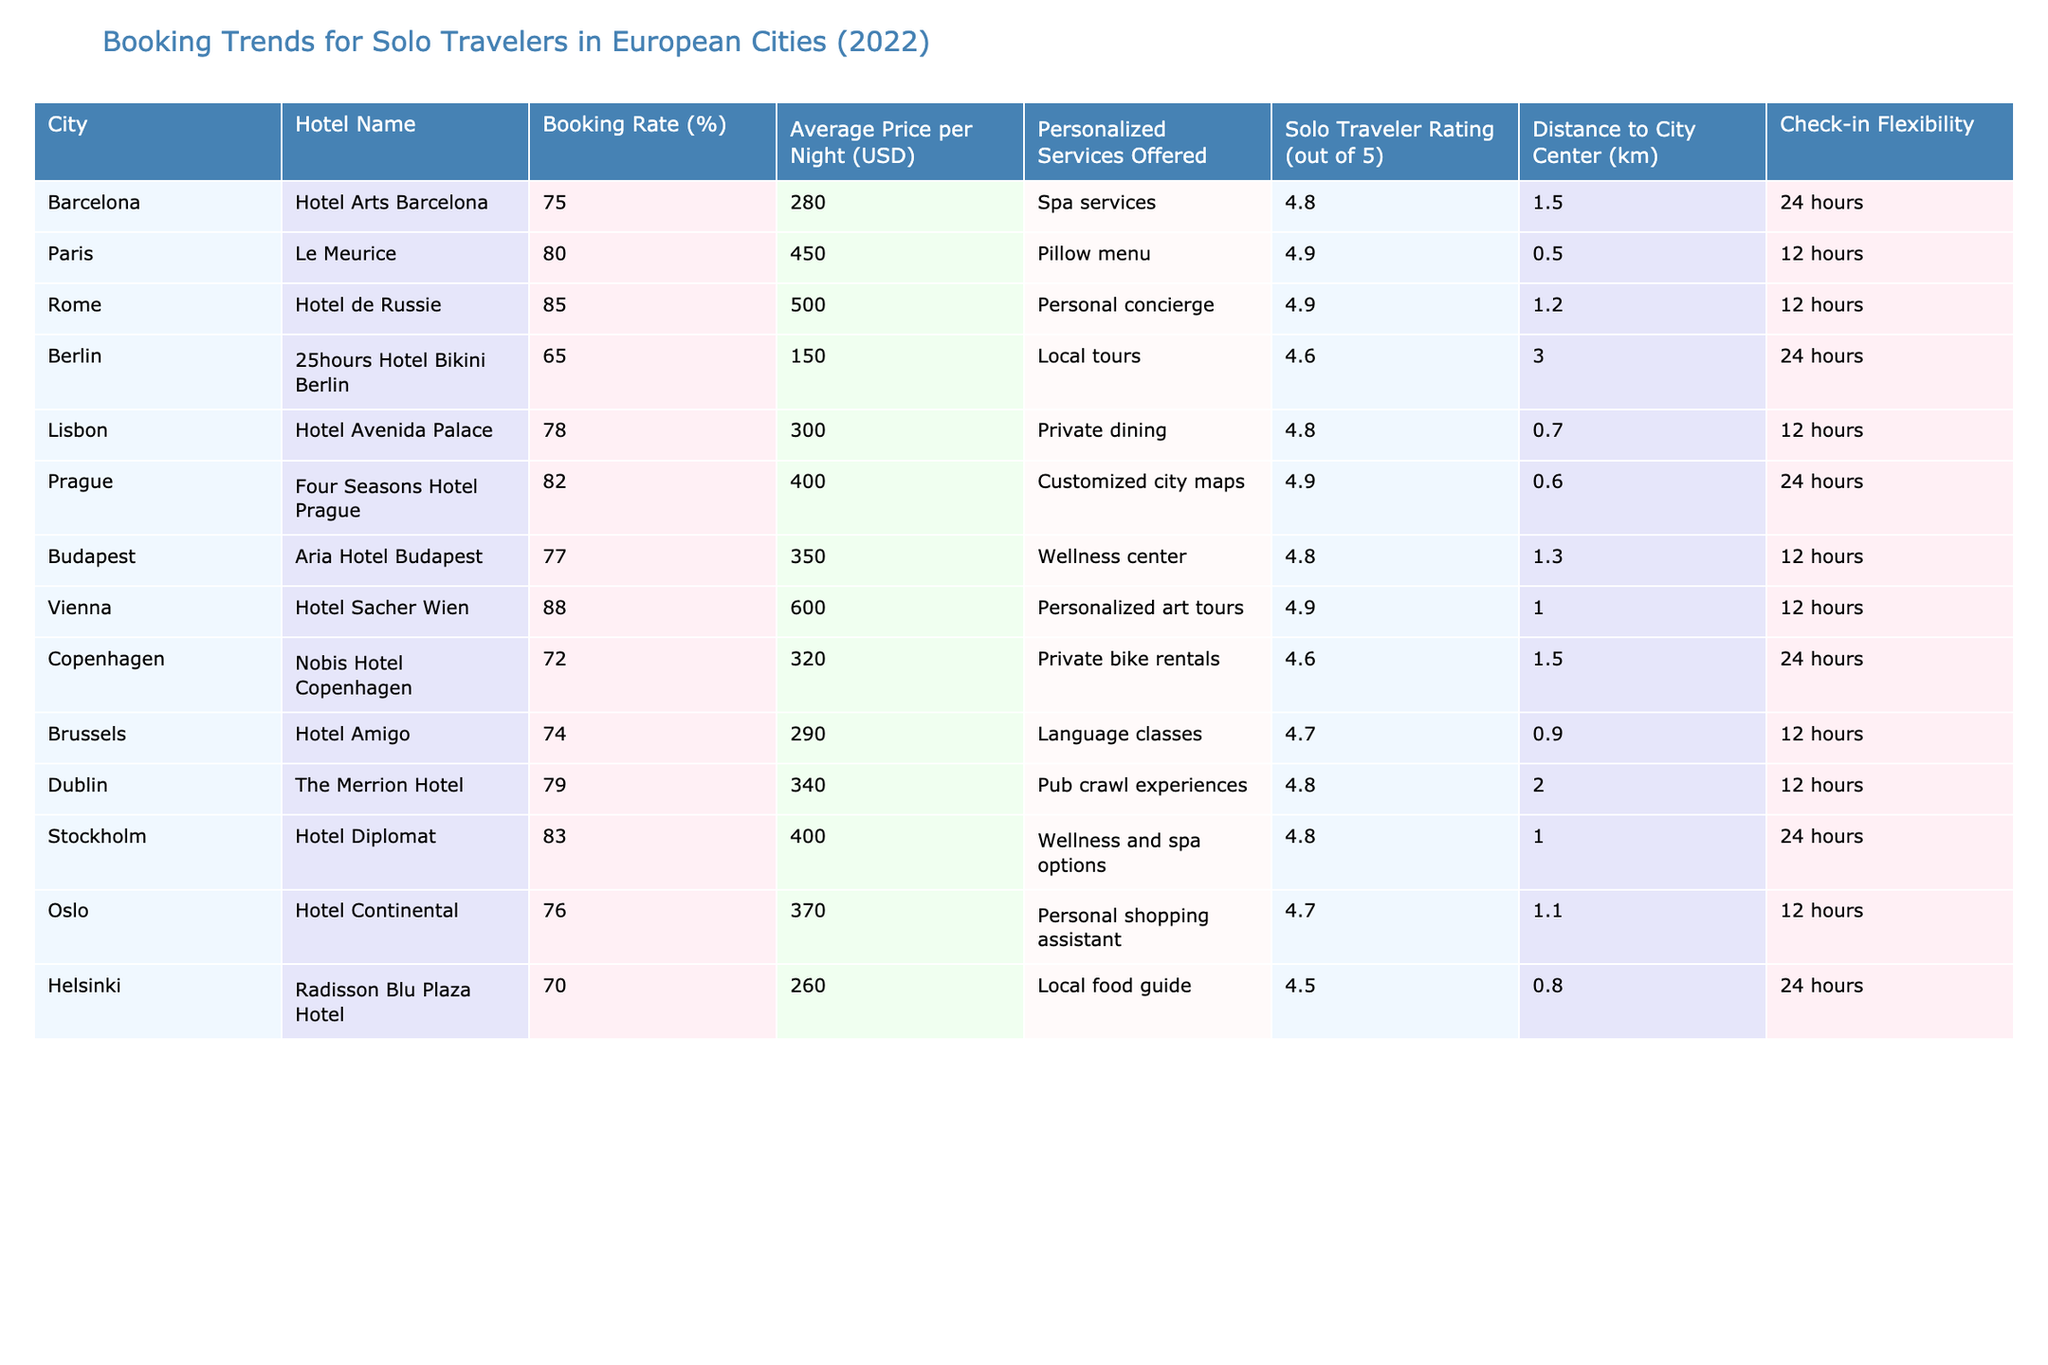What is the solo traveler rating of Le Meurice in Paris? The table shows that Le Meurice has a solo traveler rating of 4.9 out of 5.
Answer: 4.9 Which hotel has the highest booking rate among the listed hotels? According to the table, Hotel Sacher Wien has the highest booking rate at 88%.
Answer: 88% What is the average price per night among the hotels listed? By adding the prices (280 + 450 + 500 + 150 + 300 + 400 + 350 + 600 + 320 + 290 + 340 + 400 + 370 + 260) and dividing by 14 (the number of hotels), the average price is 371.43 USD.
Answer: 371.43 Is Hotel Continental in Oslo further from the city center than the average distance to city center for all hotels? First, we calculate the average distance to the city center by summing the distances (1.5 + 0.5 + 1.2 + 3.0 + 0.7 + 0.6 + 1.3 + 1.0 + 1.5 + 0.9 + 2.0 + 1.0 + 1.1 + 0.8) and dividing by 14, which gives us approximately 1.14 km. Hotel Continental is 1.1 km from the city center, which is less than the average, so the answer is no.
Answer: No Which hotel offers a personal concierge service and what is its booking rate? Upon reviewing the table, Hotel de Russie in Rome offers a personal concierge service and has a booking rate of 85%.
Answer: 85% How many hotels have a solo traveler rating of 4.8 or higher? The solo traveler ratings 4.8 or higher are from Hotel Arts Barcelona, Le Meurice, Hotel de Russie, Hotel Avenida Palace, Aria Hotel Budapest, Hotel Sacher Wien, Stockholm's Hotel Diplomat, and The Merrion Hotel, totaling 8 hotels.
Answer: 8 What is the difference in booking rates between the highest- and lowest-rated hotels? The highest booking rate is 88% (Hotel Sacher Wien) and the lowest is 65% (25hours Hotel Bikini Berlin). The difference is 88% - 65% = 23%.
Answer: 23% Which city has a hotel with the closest proximity to the city center, and what is that distance? By inspecting the table, Le Meurice in Paris is 0.5 km from the city center, making it the closest.
Answer: 0.5 km Are there any hotels that offer a wellness center as a personalized service? If so, which one and where is it located? The table indicates that Aria Hotel Budapest offers a wellness center as a personalized service. It is located in Budapest.
Answer: Yes, Aria Hotel Budapest in Budapest Which hotel has the lowest average price per night, and how much is it? The lowest average price per night is for 25hours Hotel Bikini Berlin at 150 USD.
Answer: 150 USD What is the check-in flexibility for hotels in Prague and Berlin? Four Seasons Hotel Prague offers 24 hours check-in flexibility, while 25hours Hotel Bikini Berlin offers 24 hours as well.
Answer: Both offer 24 hours 